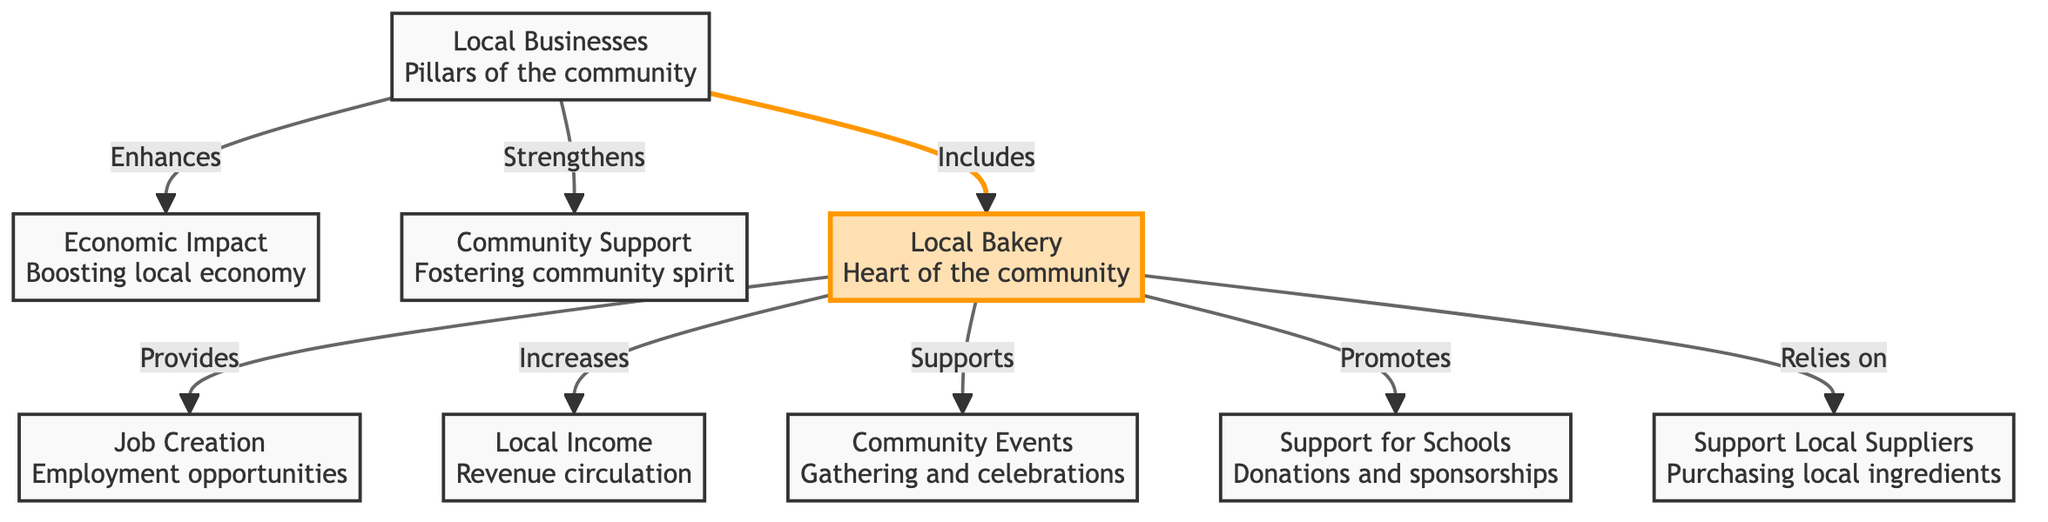What is the central node in the diagram? The diagram features a clear hierarchy, and the central node identified as the "Local Bakery" highlights its importance, being positioned at the center and distinctly marked as the heart of the community.
Answer: Local Bakery How many connections does the Local Bakery have? The Local Bakery node has five distinct connections, each pointing to various aspects of its role in the community, such as job creation, income increase, support for events, school support, and reliance on local suppliers.
Answer: 5 What does the Local Bakery enhance? The diagram flows from the Local Bakery to the economic impact node, indicating that it enhances local economic conditions, thus underlining its importance to financial growth within the community.
Answer: Economic Impact Which node does the Local Bakery support for community gatherings? The relationship depicted in the diagram shows that the Local Bakery provides support specifically for community events, indicating its role in fostering local celebrations and engagement amongst residents.
Answer: Community Events What is the Local Bakery's relationship with local suppliers? The diagram indicates a direct relationship where the Local Bakery relies on local suppliers for purchasing ingredients, illustrating the interconnected nature of local businesses and the significant role that community-based sourcing plays.
Answer: Relies on What category is the Local Bakery a part of? The diagram categorizes the Local Bakery under the umbrella of "Local Businesses," showcasing its integral role within the larger framework of community support and economic impact.
Answer: Local Businesses How does the diagram characterize the economic impact of local businesses? The diagram makes a clear connection between local businesses and economic impact through the node labeled "Economic Impact," showing how local enterprises, particularly the Local Bakery, contribute to boosting the local economy.
Answer: Boosting local economy What kind of support does the Local Bakery provide to the schools? The connection in the diagram emphasizes that the Local Bakery provides support for schools through donations and sponsorships, highlighting its contribution to educational initiatives within the community.
Answer: Donations and sponsorships What is a primary benefit of local businesses as shown in the diagram? The diagram highlights job creation as a primary benefit of local businesses, explicitly connecting this outcome with the operations of the Local Bakery and how it contributes to local employment opportunities.
Answer: Job Creation 